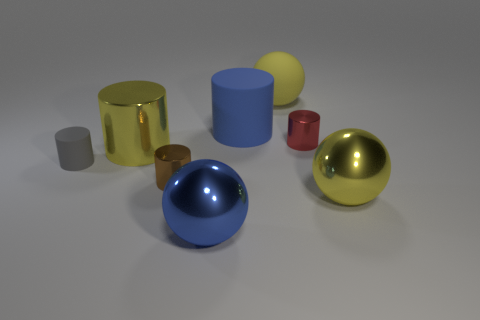Subtract all yellow spheres. How many spheres are left? 1 Subtract all green cubes. How many yellow spheres are left? 2 Add 1 cylinders. How many objects exist? 9 Subtract all yellow cylinders. How many cylinders are left? 4 Subtract all spheres. How many objects are left? 5 Subtract all green cylinders. Subtract all cyan blocks. How many cylinders are left? 5 Subtract all blue matte balls. Subtract all balls. How many objects are left? 5 Add 1 large shiny balls. How many large shiny balls are left? 3 Add 3 big blue things. How many big blue things exist? 5 Subtract 1 blue cylinders. How many objects are left? 7 